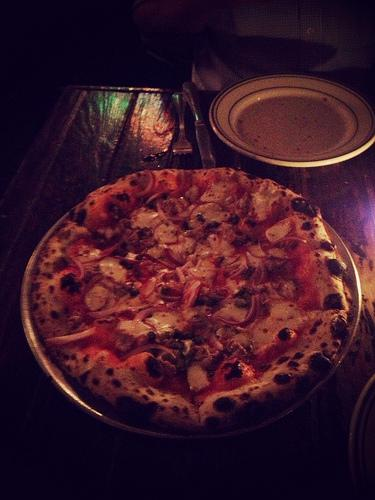What is the main food item in the image? A cooked pizza with cheese, tomato sauce, and sliced purple onions. Based on the presented captions, assess the overall quality of the pizza. The pizza appears to be of good quality with melted mozzarella, tomato sauce, and sliced purple onions but possibly a burned crust. How many food-related items are in the image, and what are their general categories? There are four main food-related items: a cooked pizza, a slice of pizza, a slice of onion, and various pizza toppings. Based on the given information, deduce a possible scenario taking place in the image. There is a served pizza on a round silver pan with cheese, tomato sauce, and sliced purple onions. Fork and knife are placed on a wooden table next to an empty round white plate. The pizza is sliced and ready to be enjoyed. What is the action being performed in the image? No action, it's a still image What is the main object in the image? a cooked pizza Is the pizza crust perfectly cooked and golden brown? No, it's not mentioned in the image. Envision a story that includes the image elements. In a cozy kitchen filled with laughter and the inviting aroma of home-cooked meals, a family gathers around a wooden table to enjoy a hearty pizza dinner. The pizza, presented on a gleaming silver platter, is a work of art, with the chef's skill evident in its enticing blend of melted cheese, tantalizing tomato sauce, and pops of purple onion. Adding to the picture-perfect scene, a well-used knife, fork, and empty white porcelain plate await their turn to play their part in the joyous meal shared by loved ones. Craft a creative caption for the image. A delectable feast awaits on a shiny platter, with every slice of the pizza oozing melted cheese, zesty tomato sauce, and tantalizing bits of purple onion. What type of food is being displayed in the image? A cooked pizza with cheese, tomato sauce, and sliced purple onions Identify the main event happening in the image. Serving a cooked pizza on a platter Is there any text or letter visible in the image? No What are the toppings on the pizza in the image? cheese, tomato sauce, and sliced purple onions Narrate an intriguing caption for the image. Sat atop a gleaming silver stage, the sumptuous pizza takes center stage, its every slice enticing the viewer with a divine blend of melted cheese, spirited tomato sauce, and the striking allure of purple onions. Describe the layout of the objects in the image. A cooked pizza with various toppings is placed on a silver platter on a wooden table, surrounded by a knife, a fork, and an empty white porcelain plate. Describe the pizza in the image. a cooked pizza on a silver platter with cheese, tomato sauce, and sliced purple onions Write a detailed caption for the image. In the image, a perfectly cooked pizza sits atop a gleaming silver platter, adorned with melted cheese, zesty tomato sauce, and slivers of eye-catching purple onion. The platter is placed on a rustic wooden table, accompanied by a knife, a fork, and an empty white porcelain plate, ready for the meal to commence. A baked pizza on platter or a pizza on the table? (Choose the best-fit answer) A baked pizza on platter Compose a narrative that includes elements from the image. On a warm summer evening, a group of friends gathered around a wooden table to share a delicious homemade pizza. The pizza, served on a shiny silver platter, was topped with melted cheese, tangy tomato sauce, and slices of purple onion. The table was set with an empty white porcelain plate, a knife, and a fork, awaiting the lively feast that would soon begin. What is the main theme of the image? Serving a cooked pizza on a platter with utensils Identify and describe the objects on the table. A cooked pizza on a silver platter, a knife, a fork, and an empty white porcelain plate 